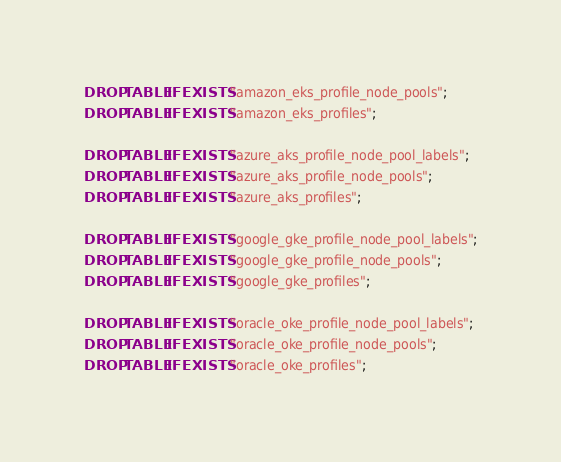Convert code to text. <code><loc_0><loc_0><loc_500><loc_500><_SQL_>DROP TABLE IF EXISTS "amazon_eks_profile_node_pools";
DROP TABLE IF EXISTS "amazon_eks_profiles";

DROP TABLE IF EXISTS "azure_aks_profile_node_pool_labels";
DROP TABLE IF EXISTS "azure_aks_profile_node_pools";
DROP TABLE IF EXISTS "azure_aks_profiles";

DROP TABLE IF EXISTS "google_gke_profile_node_pool_labels";
DROP TABLE IF EXISTS "google_gke_profile_node_pools";
DROP TABLE IF EXISTS "google_gke_profiles";

DROP TABLE IF EXISTS "oracle_oke_profile_node_pool_labels";
DROP TABLE IF EXISTS "oracle_oke_profile_node_pools";
DROP TABLE IF EXISTS "oracle_oke_profiles";
</code> 